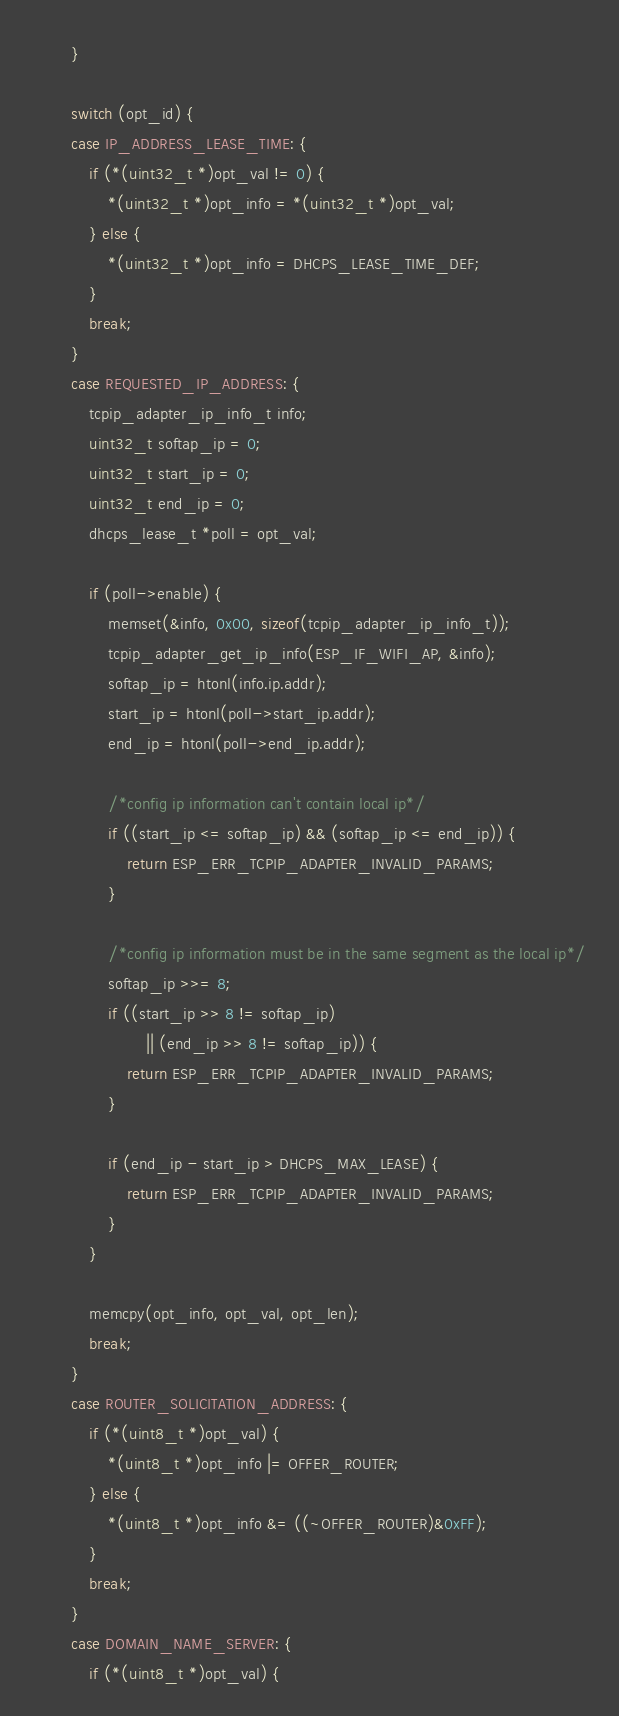<code> <loc_0><loc_0><loc_500><loc_500><_C_>        }

        switch (opt_id) {
        case IP_ADDRESS_LEASE_TIME: {
            if (*(uint32_t *)opt_val != 0) {
                *(uint32_t *)opt_info = *(uint32_t *)opt_val;
            } else {
                *(uint32_t *)opt_info = DHCPS_LEASE_TIME_DEF;
            }
            break;
        }
        case REQUESTED_IP_ADDRESS: {
            tcpip_adapter_ip_info_t info;
            uint32_t softap_ip = 0;
            uint32_t start_ip = 0;
            uint32_t end_ip = 0;
            dhcps_lease_t *poll = opt_val;

            if (poll->enable) {
                memset(&info, 0x00, sizeof(tcpip_adapter_ip_info_t));
                tcpip_adapter_get_ip_info(ESP_IF_WIFI_AP, &info);
                softap_ip = htonl(info.ip.addr);
                start_ip = htonl(poll->start_ip.addr);
                end_ip = htonl(poll->end_ip.addr);

                /*config ip information can't contain local ip*/
                if ((start_ip <= softap_ip) && (softap_ip <= end_ip)) {
                    return ESP_ERR_TCPIP_ADAPTER_INVALID_PARAMS;
                }

                /*config ip information must be in the same segment as the local ip*/
                softap_ip >>= 8;
                if ((start_ip >> 8 != softap_ip)
                        || (end_ip >> 8 != softap_ip)) {
                    return ESP_ERR_TCPIP_ADAPTER_INVALID_PARAMS;
                }

                if (end_ip - start_ip > DHCPS_MAX_LEASE) {
                    return ESP_ERR_TCPIP_ADAPTER_INVALID_PARAMS;
                }
            }

            memcpy(opt_info, opt_val, opt_len);
            break;
        }
        case ROUTER_SOLICITATION_ADDRESS: {
            if (*(uint8_t *)opt_val) {
                *(uint8_t *)opt_info |= OFFER_ROUTER;
            } else {
                *(uint8_t *)opt_info &= ((~OFFER_ROUTER)&0xFF);
            }
            break;
        }
        case DOMAIN_NAME_SERVER: {
            if (*(uint8_t *)opt_val) {</code> 